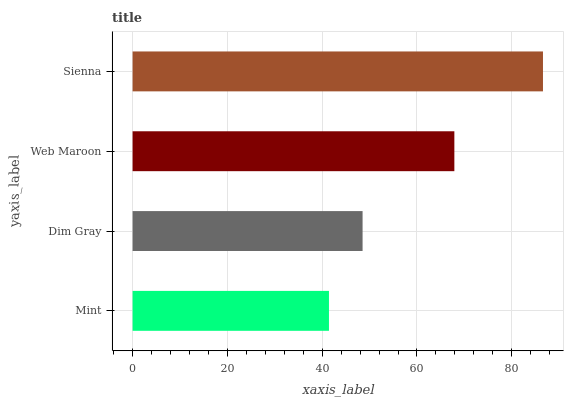Is Mint the minimum?
Answer yes or no. Yes. Is Sienna the maximum?
Answer yes or no. Yes. Is Dim Gray the minimum?
Answer yes or no. No. Is Dim Gray the maximum?
Answer yes or no. No. Is Dim Gray greater than Mint?
Answer yes or no. Yes. Is Mint less than Dim Gray?
Answer yes or no. Yes. Is Mint greater than Dim Gray?
Answer yes or no. No. Is Dim Gray less than Mint?
Answer yes or no. No. Is Web Maroon the high median?
Answer yes or no. Yes. Is Dim Gray the low median?
Answer yes or no. Yes. Is Mint the high median?
Answer yes or no. No. Is Mint the low median?
Answer yes or no. No. 